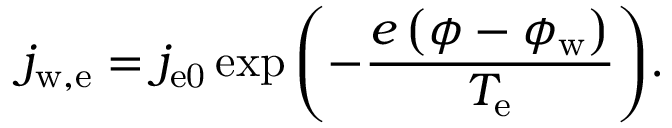<formula> <loc_0><loc_0><loc_500><loc_500>j _ { w , e } = j _ { e 0 } \exp { \left ( - \frac { e \left ( \phi - \phi _ { w } \right ) } { T _ { e } } \right ) } .</formula> 